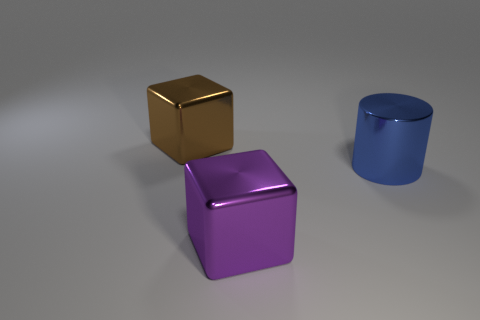Add 1 brown metallic objects. How many objects exist? 4 Subtract all big red blocks. Subtract all big brown things. How many objects are left? 2 Add 3 blue metallic things. How many blue metallic things are left? 4 Add 3 purple shiny objects. How many purple shiny objects exist? 4 Subtract all purple blocks. How many blocks are left? 1 Subtract 0 brown spheres. How many objects are left? 3 Subtract all cylinders. How many objects are left? 2 Subtract all brown blocks. Subtract all yellow spheres. How many blocks are left? 1 Subtract all purple cylinders. How many gray blocks are left? 0 